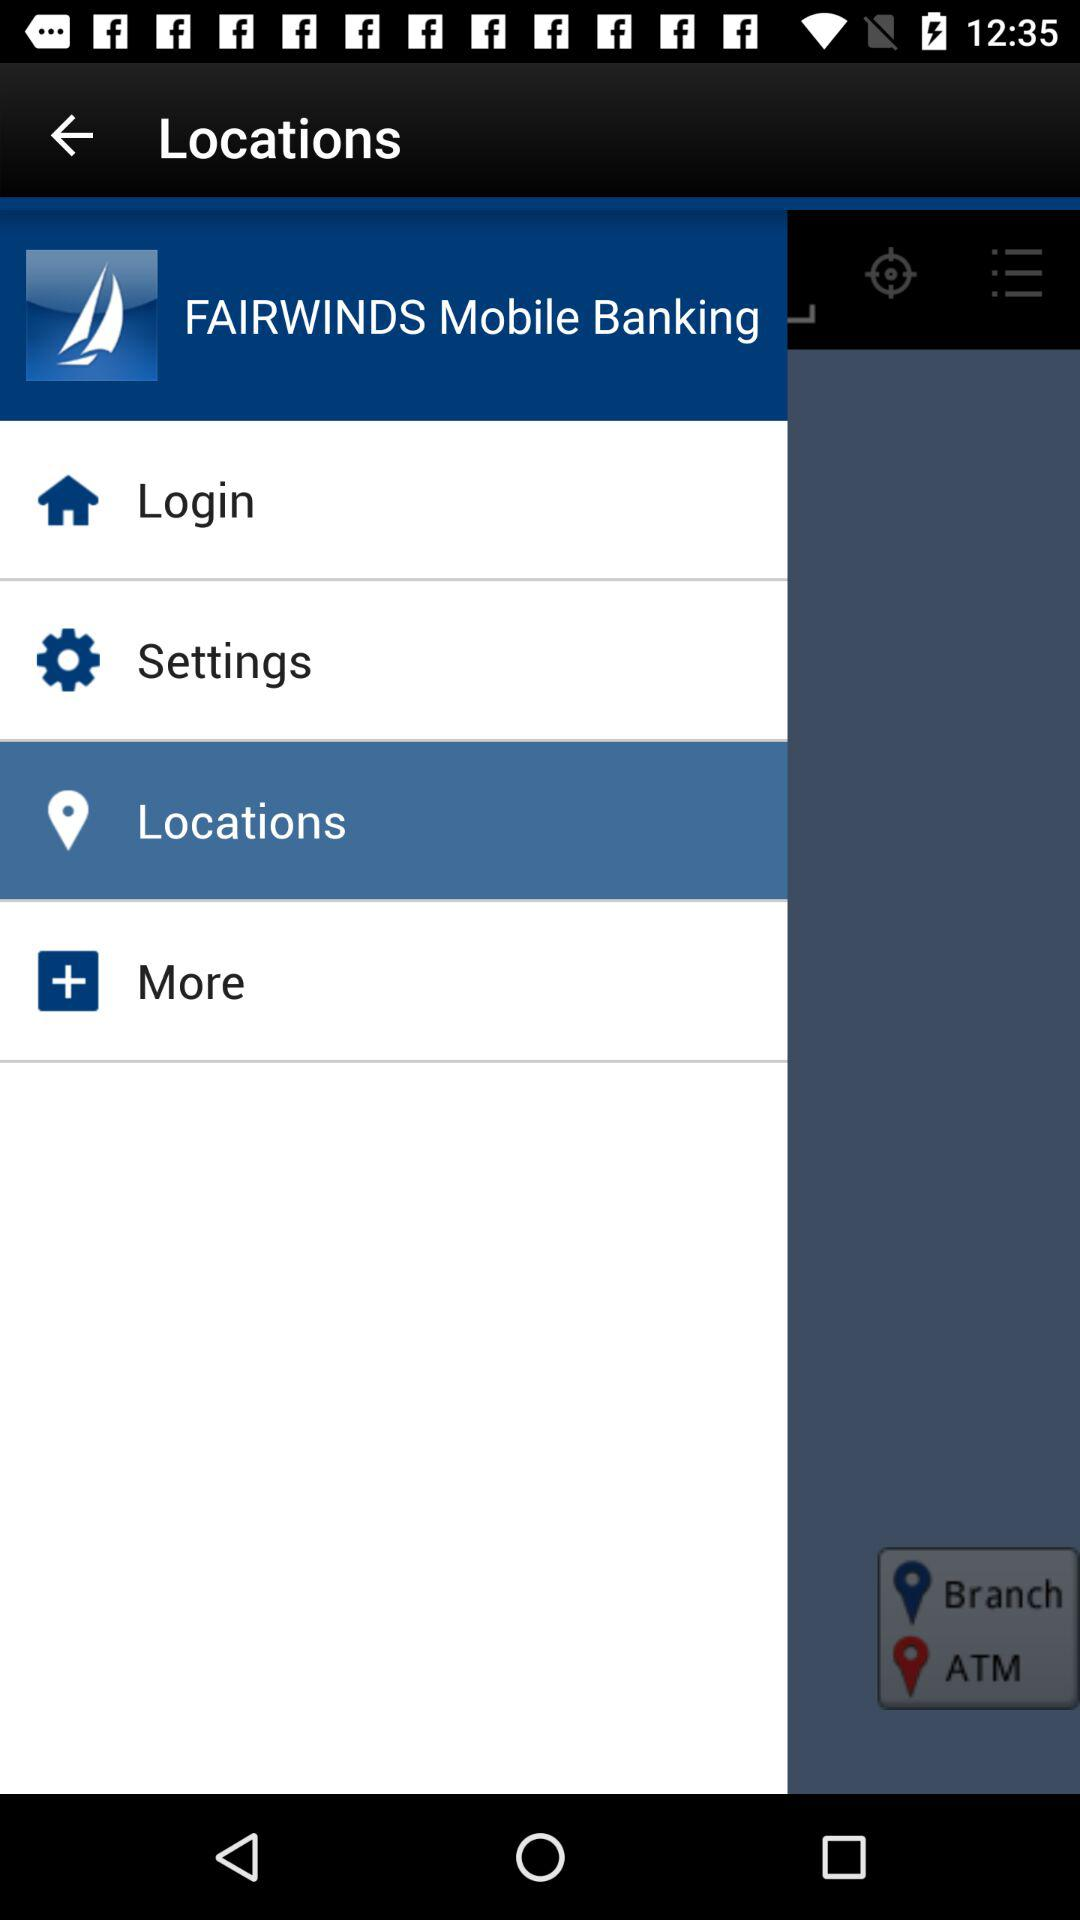What is the app name? The app name is "FAIRWINDS Mobile Banking". 